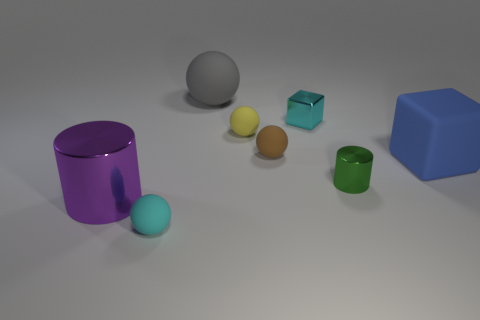There is a object that is the same color as the tiny block; what is it made of?
Your response must be concise. Rubber. There is a tiny cyan thing in front of the big metal cylinder; is its shape the same as the big object behind the yellow rubber ball?
Your answer should be very brief. Yes. Do the tiny cyan thing in front of the yellow thing and the tiny green thing have the same material?
Your response must be concise. No. Are there any large red blocks made of the same material as the large purple object?
Your answer should be very brief. No. What number of green things are small balls or small things?
Your response must be concise. 1. Is the number of small metal objects that are in front of the large blue object greater than the number of small yellow shiny cylinders?
Your answer should be compact. Yes. Is the purple thing the same size as the matte cube?
Your answer should be very brief. Yes. The block that is made of the same material as the tiny brown thing is what color?
Your answer should be compact. Blue. There is a thing that is the same color as the tiny metallic cube; what shape is it?
Keep it short and to the point. Sphere. Is the number of balls that are on the left side of the small cyan rubber sphere the same as the number of tiny cyan objects left of the green metal thing?
Offer a terse response. No. 